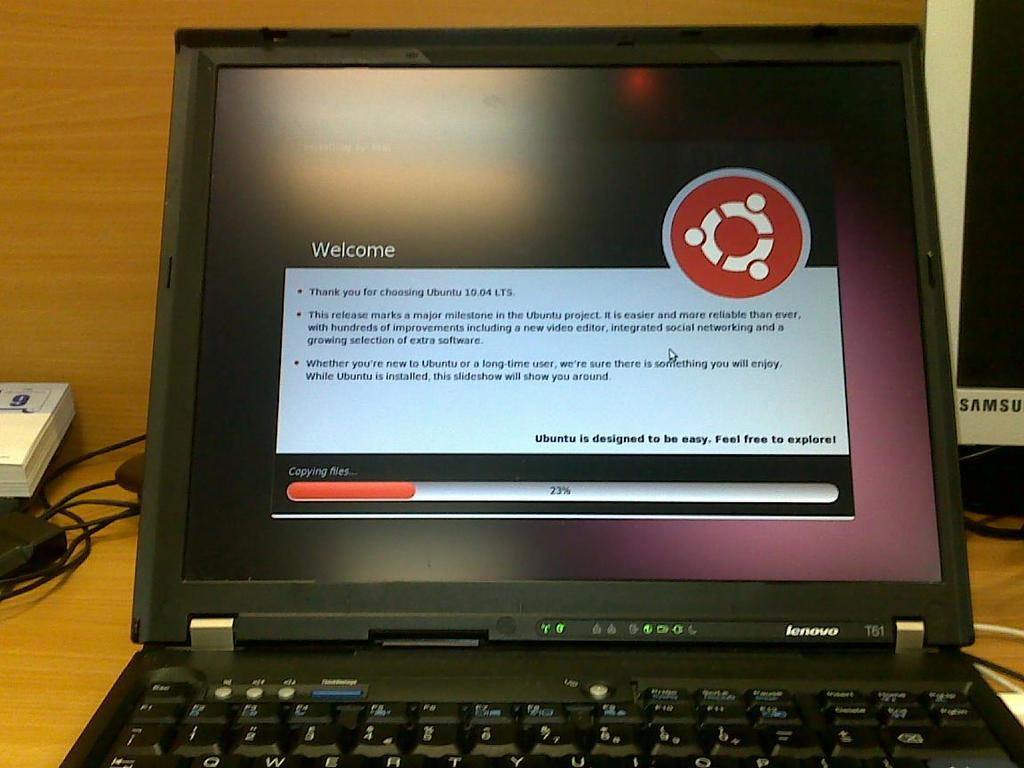<image>
Share a concise interpretation of the image provided. A black laptop computer with the welcome screen from Ubuntu 10.04 LTS. 